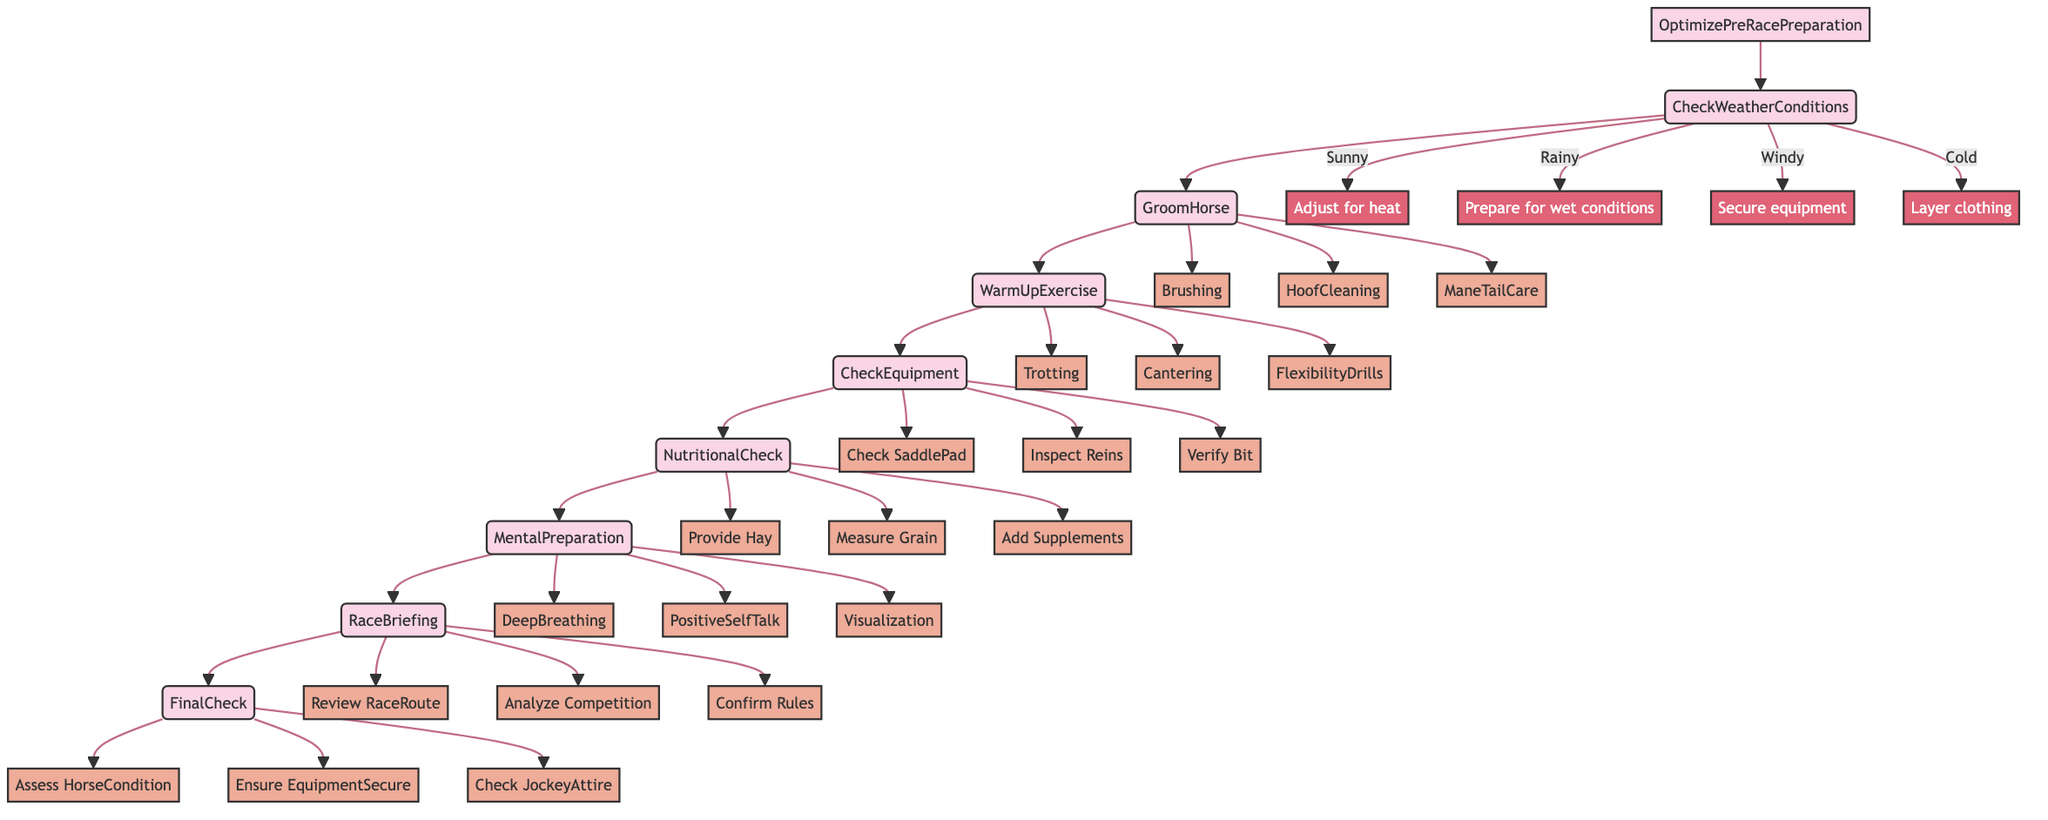What is the first step in the optimization process? The first step is to check the weather conditions for race day. This is indicated as the starting node in the flowchart.
Answer: CheckWeatherConditions How many main steps are there in the Optimize Pre-Race Preparation? The flowchart outlines eight main steps which include CheckWeatherConditions, GroomHorse, WarmUpExercise, CheckEquipment, NutritionalCheck, MentalPreparation, RaceBriefing, and FinalCheck.
Answer: Eight Which step follows GroomHorse in the optimization process? After GroomHorse, the next step in the sequence is WarmUpExercise, as indicated by the direct arrow leading from GroomHorse to WarmUpExercise.
Answer: WarmUpExercise What activities are included in the GroomHorse step? The activities listed under GroomHorse include Brushing, HoofCleaning, and ManeTailCare. These activities are represented as child nodes branching from the GroomHorse step.
Answer: Brushing, HoofCleaning, ManeTailCare What adjustments are made for rainy weather? For rainy weather, the preparation involves preparing for wet conditions. This is indicated as a specific condition branching from CheckWeatherConditions.
Answer: Prepare for wet conditions Which tools are needed for the CheckEquipment step? The tools required for the CheckEquipment step include Saddle, Bridle, and Stirrups. These tools are listed as essential for ensuring the racing equipment is ready.
Answer: Saddle, Bridle, Stirrups What is the last step before heading to the starting gate? The last step prior to heading to the starting gate is FinalCheck, which includes performing a final inspection on the horse and equipment.
Answer: FinalCheck How many techniques are listed under MentalPreparation? There are three techniques listed for MentalPreparation: DeepBreathing, PositiveSelfTalk, and Visualization.
Answer: Three What does the RaceBriefing step involve? The RaceBriefing step involves reviewing race details which include RaceRoute, CompetitionAnalysis, and Rules, as indicated by the topics that branch from RaceBriefing.
Answer: Review RaceRoute, Analyze Competition, Confirm Rules 